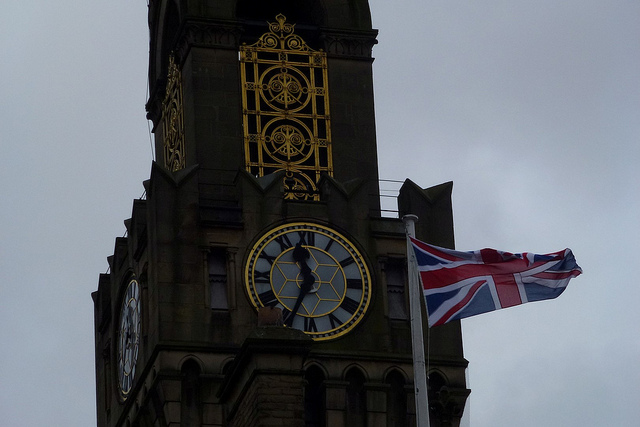Is there any historic significance to this clock tower? Yes, this clock tower holds significant historical value as it was constructed in the late 19th century. It serves not only as a timekeeping piece but also as a landmark for historical heritage of the area. Can you tell more about the events or figures associated with its history? Certainly! The clock tower was often featured in key events of the city, such as New Year's celebrations and other public gatherings. It has also been a witness to many key political and social events throughout its history. 